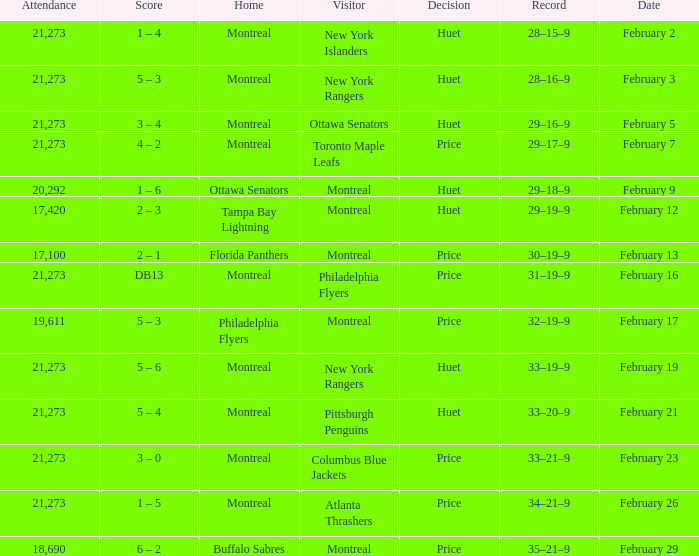Who was the visiting team at the game when the Canadiens had a record of 30–19–9? Montreal. 